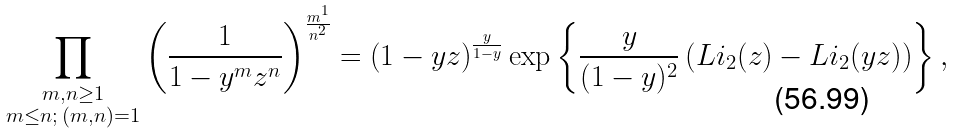Convert formula to latex. <formula><loc_0><loc_0><loc_500><loc_500>\prod _ { \substack { m , n \geq 1 \\ m \leq n ; \, ( m , n ) = 1 } } \left ( \frac { 1 } { 1 - y ^ { m } z ^ { n } } \right ) ^ { \frac { m ^ { 1 } } { n ^ { 2 } } } = \left ( 1 - y z \right ) ^ { \frac { y } { 1 - y } } \exp \left \{ \frac { y } { ( 1 - y ) ^ { 2 } } \left ( L i _ { 2 } ( z ) - L i _ { 2 } ( y z ) \right ) \right \} ,</formula> 